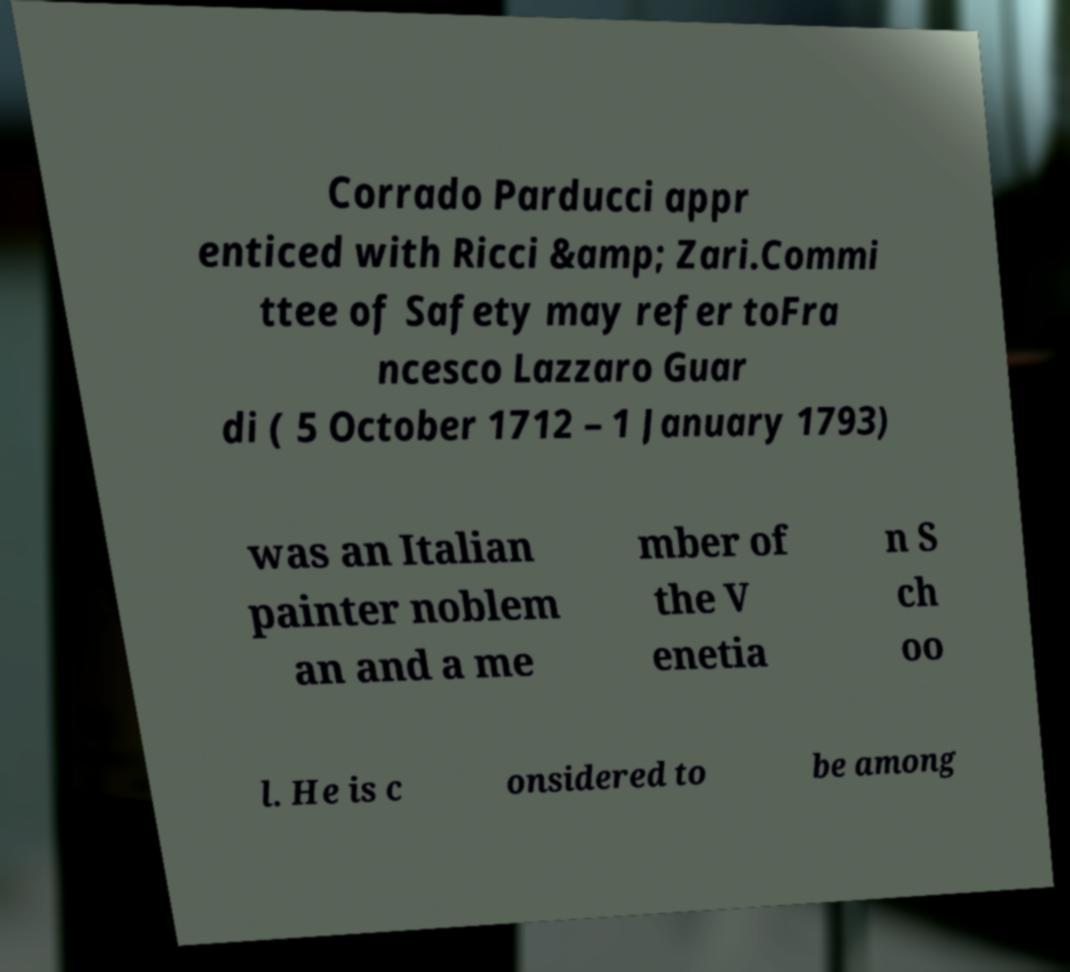What messages or text are displayed in this image? I need them in a readable, typed format. Corrado Parducci appr enticed with Ricci &amp; Zari.Commi ttee of Safety may refer toFra ncesco Lazzaro Guar di ( 5 October 1712 – 1 January 1793) was an Italian painter noblem an and a me mber of the V enetia n S ch oo l. He is c onsidered to be among 